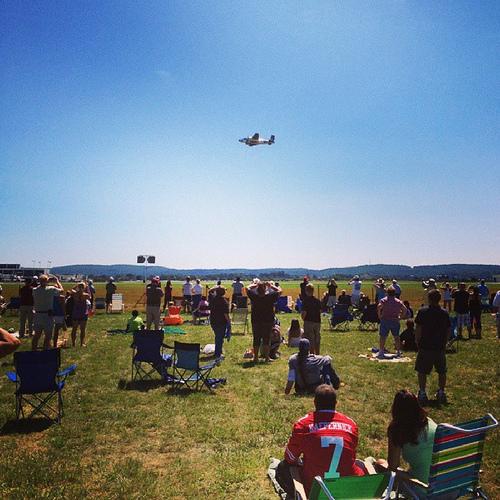Is the chair yellow or blue? The chair is blue. 